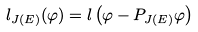<formula> <loc_0><loc_0><loc_500><loc_500>l _ { J ( E ) } ( \varphi ) = l \left ( \varphi - P _ { J ( E ) } \varphi \right )</formula> 